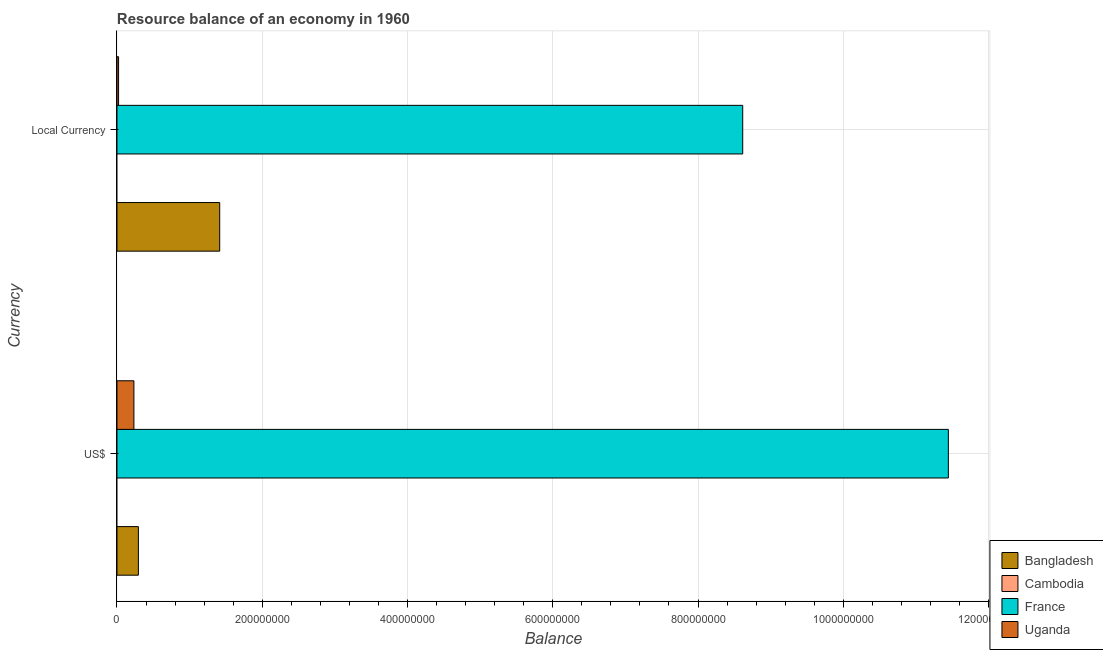How many different coloured bars are there?
Offer a very short reply. 3. How many groups of bars are there?
Make the answer very short. 2. Are the number of bars on each tick of the Y-axis equal?
Offer a terse response. Yes. What is the label of the 1st group of bars from the top?
Offer a terse response. Local Currency. What is the resource balance in us$ in Cambodia?
Make the answer very short. 0. Across all countries, what is the maximum resource balance in constant us$?
Your answer should be very brief. 8.62e+08. Across all countries, what is the minimum resource balance in constant us$?
Your answer should be very brief. 0. What is the total resource balance in us$ in the graph?
Your response must be concise. 1.20e+09. What is the difference between the resource balance in constant us$ in Bangladesh and that in Uganda?
Offer a terse response. 1.39e+08. What is the difference between the resource balance in constant us$ in Cambodia and the resource balance in us$ in Bangladesh?
Ensure brevity in your answer.  -2.95e+07. What is the average resource balance in us$ per country?
Provide a short and direct response. 2.99e+08. What is the difference between the resource balance in us$ and resource balance in constant us$ in France?
Provide a succinct answer. 2.83e+08. In how many countries, is the resource balance in us$ greater than 840000000 units?
Keep it short and to the point. 1. What is the ratio of the resource balance in us$ in Bangladesh to that in France?
Offer a terse response. 0.03. Is the resource balance in us$ in Bangladesh less than that in France?
Offer a terse response. Yes. In how many countries, is the resource balance in us$ greater than the average resource balance in us$ taken over all countries?
Offer a terse response. 1. Are all the bars in the graph horizontal?
Keep it short and to the point. Yes. How many countries are there in the graph?
Offer a very short reply. 4. What is the difference between two consecutive major ticks on the X-axis?
Give a very brief answer. 2.00e+08. Does the graph contain any zero values?
Your answer should be very brief. Yes. What is the title of the graph?
Offer a very short reply. Resource balance of an economy in 1960. Does "Central African Republic" appear as one of the legend labels in the graph?
Provide a succinct answer. No. What is the label or title of the X-axis?
Your answer should be compact. Balance. What is the label or title of the Y-axis?
Your response must be concise. Currency. What is the Balance of Bangladesh in US$?
Ensure brevity in your answer.  2.95e+07. What is the Balance in Cambodia in US$?
Ensure brevity in your answer.  0. What is the Balance of France in US$?
Provide a short and direct response. 1.14e+09. What is the Balance of Uganda in US$?
Give a very brief answer. 2.33e+07. What is the Balance of Bangladesh in Local Currency?
Keep it short and to the point. 1.41e+08. What is the Balance in France in Local Currency?
Offer a very short reply. 8.62e+08. What is the Balance in Uganda in Local Currency?
Your response must be concise. 2.22e+06. Across all Currency, what is the maximum Balance of Bangladesh?
Offer a terse response. 1.41e+08. Across all Currency, what is the maximum Balance in France?
Provide a short and direct response. 1.14e+09. Across all Currency, what is the maximum Balance in Uganda?
Keep it short and to the point. 2.33e+07. Across all Currency, what is the minimum Balance of Bangladesh?
Ensure brevity in your answer.  2.95e+07. Across all Currency, what is the minimum Balance of France?
Give a very brief answer. 8.62e+08. Across all Currency, what is the minimum Balance of Uganda?
Your answer should be compact. 2.22e+06. What is the total Balance in Bangladesh in the graph?
Offer a terse response. 1.71e+08. What is the total Balance in France in the graph?
Your answer should be very brief. 2.01e+09. What is the total Balance in Uganda in the graph?
Your response must be concise. 2.56e+07. What is the difference between the Balance in Bangladesh in US$ and that in Local Currency?
Your answer should be compact. -1.12e+08. What is the difference between the Balance in France in US$ and that in Local Currency?
Give a very brief answer. 2.83e+08. What is the difference between the Balance of Uganda in US$ and that in Local Currency?
Offer a terse response. 2.11e+07. What is the difference between the Balance in Bangladesh in US$ and the Balance in France in Local Currency?
Make the answer very short. -8.32e+08. What is the difference between the Balance of Bangladesh in US$ and the Balance of Uganda in Local Currency?
Your answer should be very brief. 2.72e+07. What is the difference between the Balance of France in US$ and the Balance of Uganda in Local Currency?
Your answer should be compact. 1.14e+09. What is the average Balance of Bangladesh per Currency?
Give a very brief answer. 8.55e+07. What is the average Balance of Cambodia per Currency?
Your response must be concise. 0. What is the average Balance of France per Currency?
Give a very brief answer. 1.00e+09. What is the average Balance of Uganda per Currency?
Ensure brevity in your answer.  1.28e+07. What is the difference between the Balance in Bangladesh and Balance in France in US$?
Provide a short and direct response. -1.12e+09. What is the difference between the Balance of Bangladesh and Balance of Uganda in US$?
Your response must be concise. 6.14e+06. What is the difference between the Balance of France and Balance of Uganda in US$?
Ensure brevity in your answer.  1.12e+09. What is the difference between the Balance in Bangladesh and Balance in France in Local Currency?
Your answer should be compact. -7.20e+08. What is the difference between the Balance in Bangladesh and Balance in Uganda in Local Currency?
Your answer should be compact. 1.39e+08. What is the difference between the Balance of France and Balance of Uganda in Local Currency?
Your answer should be very brief. 8.59e+08. What is the ratio of the Balance in Bangladesh in US$ to that in Local Currency?
Provide a short and direct response. 0.21. What is the ratio of the Balance of France in US$ to that in Local Currency?
Offer a terse response. 1.33. What is the ratio of the Balance of Uganda in US$ to that in Local Currency?
Your answer should be very brief. 10.49. What is the difference between the highest and the second highest Balance in Bangladesh?
Keep it short and to the point. 1.12e+08. What is the difference between the highest and the second highest Balance of France?
Ensure brevity in your answer.  2.83e+08. What is the difference between the highest and the second highest Balance in Uganda?
Offer a very short reply. 2.11e+07. What is the difference between the highest and the lowest Balance of Bangladesh?
Offer a very short reply. 1.12e+08. What is the difference between the highest and the lowest Balance of France?
Your answer should be compact. 2.83e+08. What is the difference between the highest and the lowest Balance of Uganda?
Your response must be concise. 2.11e+07. 